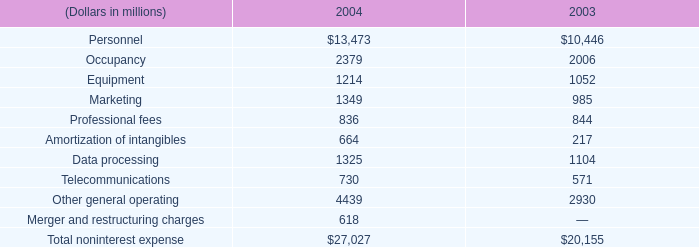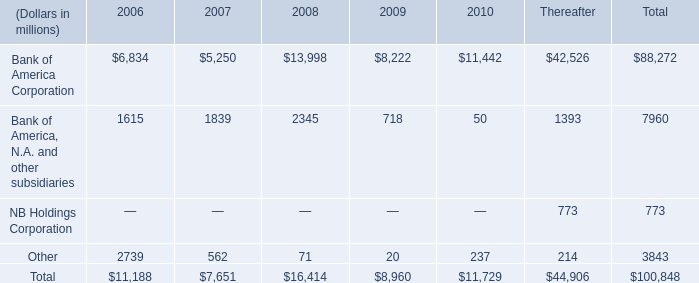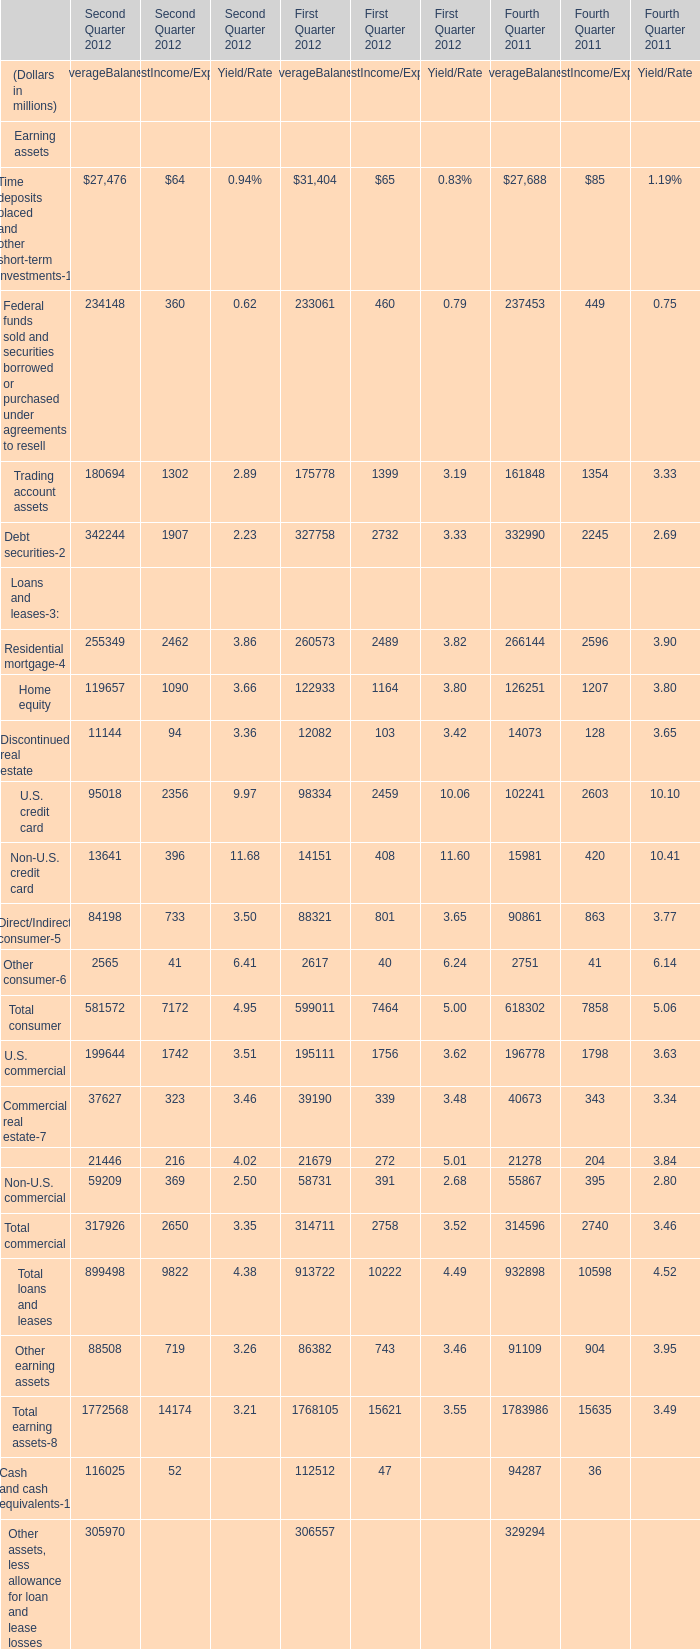What's the average of Commercial lease financing of First Quarter 2012 AverageBalance, and Bank of America Corporation of 2006 ? 
Computations: ((21679.0 + 6834.0) / 2)
Answer: 14256.5. 